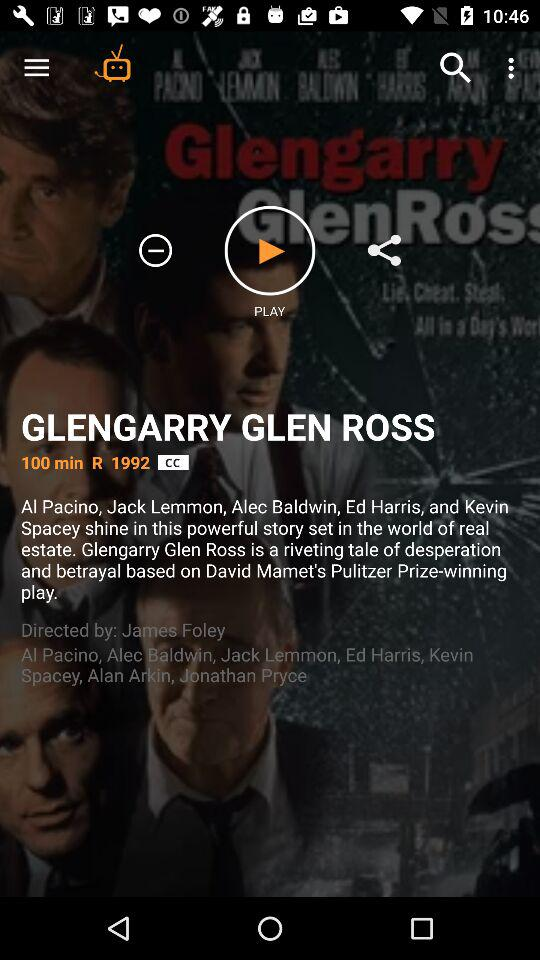Who directed the show? The show was directed by James Foley. 